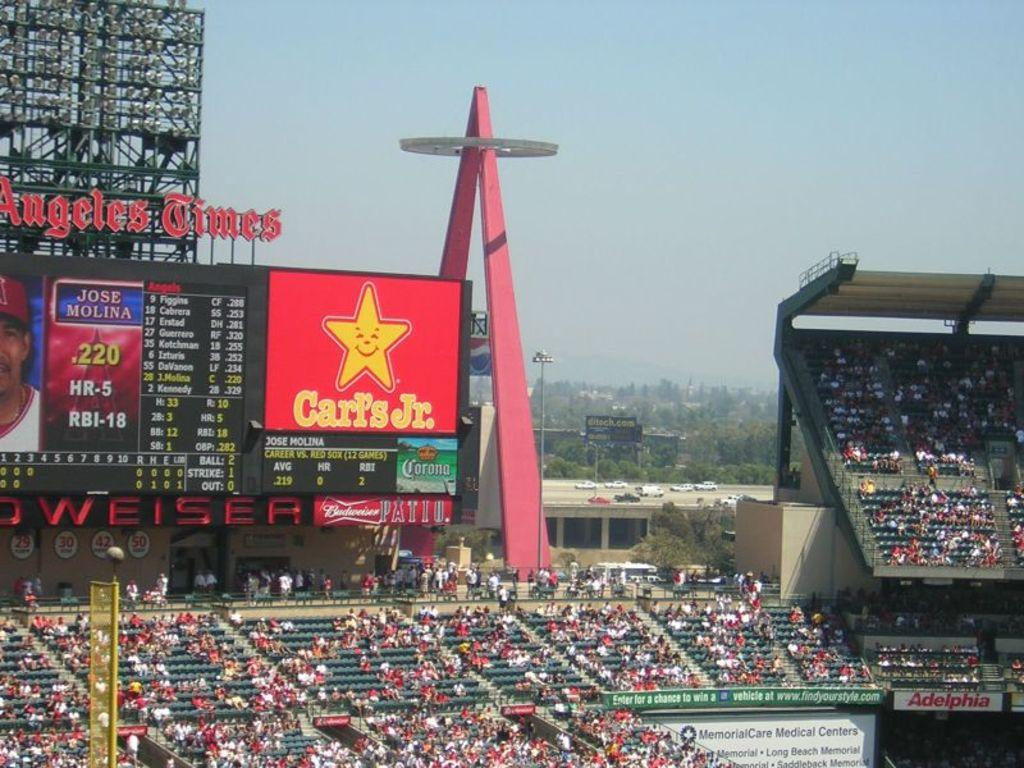Provide a one-sentence caption for the provided image. a sports arena with Carl's Jr., and Budweiser advertised in the background. 